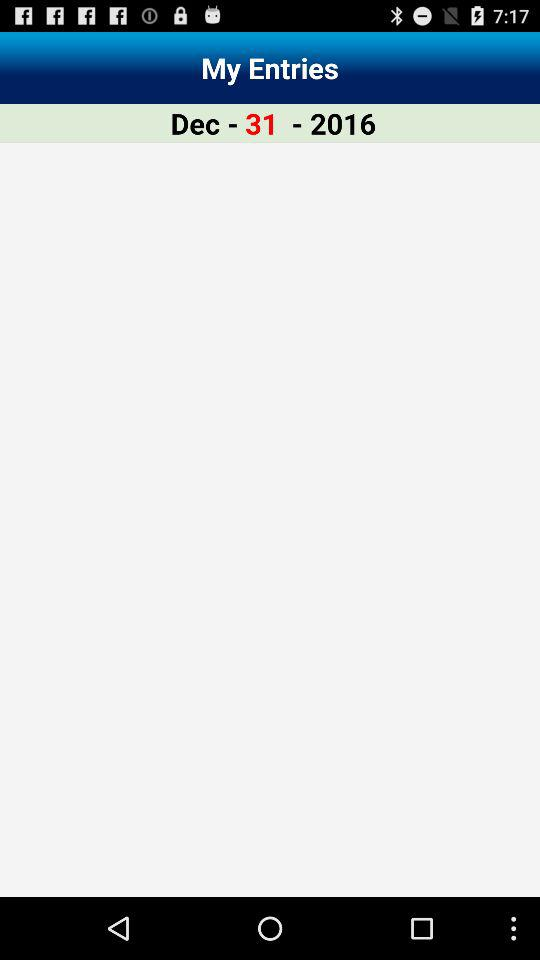How many entries are there?
When the provided information is insufficient, respond with <no answer>. <no answer> 